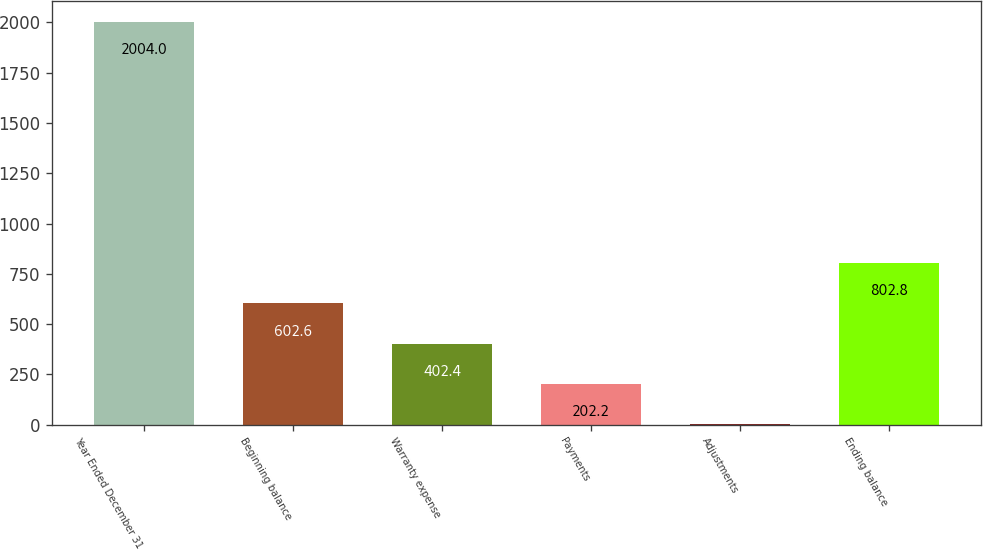<chart> <loc_0><loc_0><loc_500><loc_500><bar_chart><fcel>Year Ended December 31<fcel>Beginning balance<fcel>Warranty expense<fcel>Payments<fcel>Adjustments<fcel>Ending balance<nl><fcel>2004<fcel>602.6<fcel>402.4<fcel>202.2<fcel>2<fcel>802.8<nl></chart> 